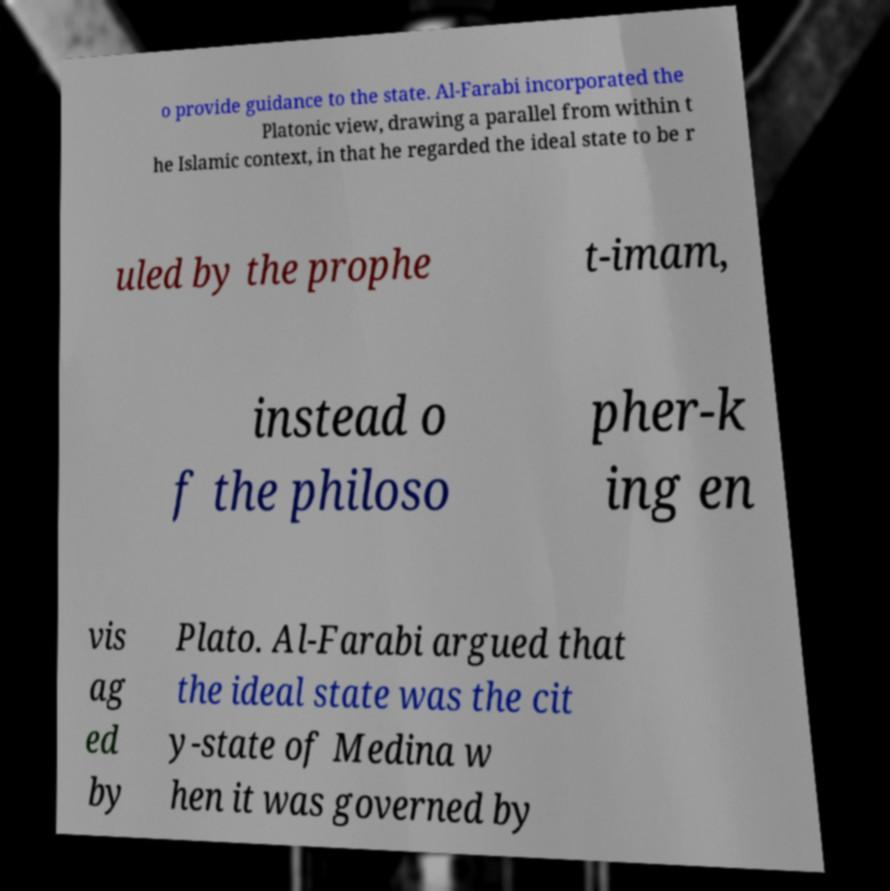What messages or text are displayed in this image? I need them in a readable, typed format. o provide guidance to the state. Al-Farabi incorporated the Platonic view, drawing a parallel from within t he Islamic context, in that he regarded the ideal state to be r uled by the prophe t-imam, instead o f the philoso pher-k ing en vis ag ed by Plato. Al-Farabi argued that the ideal state was the cit y-state of Medina w hen it was governed by 